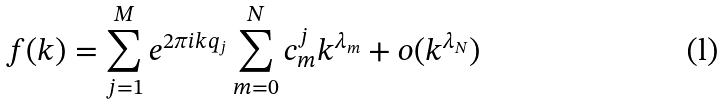<formula> <loc_0><loc_0><loc_500><loc_500>f ( k ) = \sum _ { j = 1 } ^ { M } e ^ { 2 \pi i k q _ { j } } \sum _ { m = 0 } ^ { N } c _ { m } ^ { j } k ^ { \lambda _ { m } } + o ( k ^ { \lambda _ { N } } )</formula> 